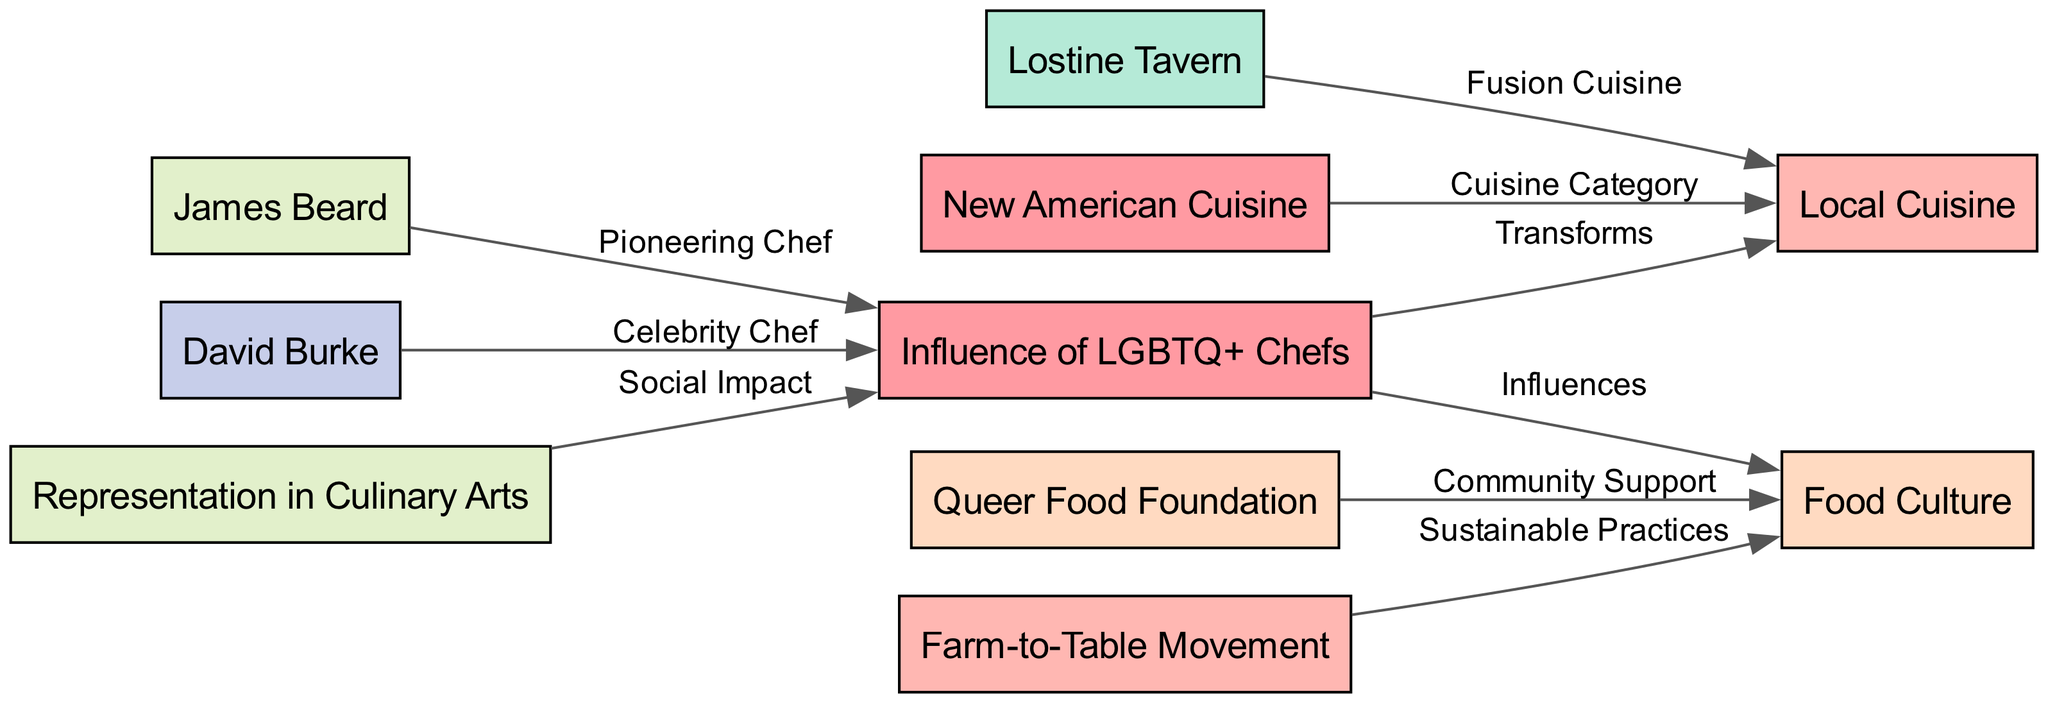What is the main influence of LGBTQ+ Chefs on local cuisine? The diagram indicates that the influence is to "Transforms" local cuisine. This relationship is directly shown between the node "Influence of LGBTQ+ Chefs" and "Local Cuisine."
Answer: Transforms How many nodes are in the diagram? By counting the number of unique nodes listed, there are a total of 10 nodes present in the diagram.
Answer: 10 Which chef is labeled as a pioneering chef in the diagram? The diagram shows a directed edge from "James Beard" to "Influence of LGBTQ+ Chefs," indicating that James Beard is recognized as a pioneering chef.
Answer: James Beard What type of cuisine category does David Burke represent? The diagram outlines an edge from "David Burke" to "Influence of LGBTQ+ Chefs," indicating his significance. He is associated with the broader context of New American Cuisine as shown in the diagram.
Answer: New American Cuisine What organization supports local food culture through community support? The diagram identifies an edge from the "Queer Food Foundation" to "Food Culture," stating that it provides "Community Support" for local food culture.
Answer: Queer Food Foundation How does the Farm-to-Table Movement relate to food culture? The edge from "Farm-to-Table Movement" to "Food Culture" indicates that it introduces "Sustainable Practices," thus relating these practices to food culture.
Answer: Sustainable Practices What is the relationship between representation in culinary arts and LGBTQ+ chefs? The diagram shows a direct edge from "Representation in Culinary Arts" to "Influence of LGBTQ+ Chefs," identifying a link reflected as a "Social Impact" from the representation on chefs' influence.
Answer: Social Impact Which node is connected to local cuisine through fusion cuisine? The node "Lostine Tavern" is connected to "Local Cuisine" and is specified to do so via "Fusion Cuisine" as indicated by the edge in the diagram.
Answer: Lostine Tavern What type of cuisine does the influence of LGBTQ+ chefs incorporate? The diagram suggests that the influence incorporates "New American Cuisine," as indicated by the edge from this cuisine category to "Local Cuisine."
Answer: New American Cuisine What does the Queer Food Foundation signify in the context of food culture? The diagram denotes that the Queer Food Foundation provides "Community Support," which is crucial for enhancing the local food culture.
Answer: Community Support 